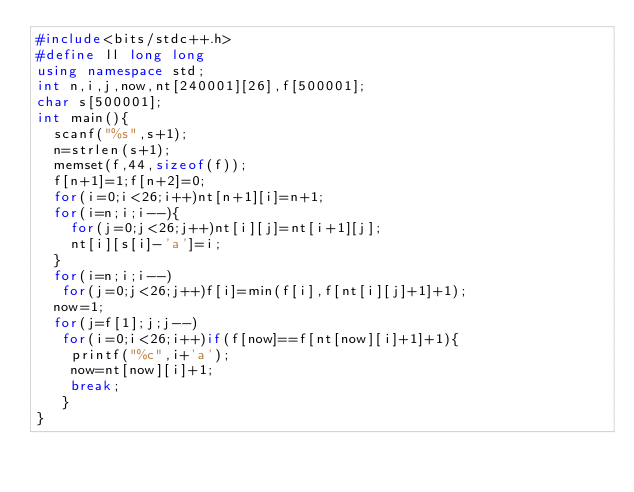Convert code to text. <code><loc_0><loc_0><loc_500><loc_500><_C++_>#include<bits/stdc++.h>
#define ll long long
using namespace std;
int n,i,j,now,nt[240001][26],f[500001];
char s[500001];
int main(){
	scanf("%s",s+1);
	n=strlen(s+1);
	memset(f,44,sizeof(f));
	f[n+1]=1;f[n+2]=0;
	for(i=0;i<26;i++)nt[n+1][i]=n+1;
	for(i=n;i;i--){
		for(j=0;j<26;j++)nt[i][j]=nt[i+1][j];
		nt[i][s[i]-'a']=i;
	}
	for(i=n;i;i--)
	 for(j=0;j<26;j++)f[i]=min(f[i],f[nt[i][j]+1]+1);
	now=1;
	for(j=f[1];j;j--)
	 for(i=0;i<26;i++)if(f[now]==f[nt[now][i]+1]+1){
	 	printf("%c",i+'a');
	 	now=nt[now][i]+1;
	 	break;
	 }
}</code> 